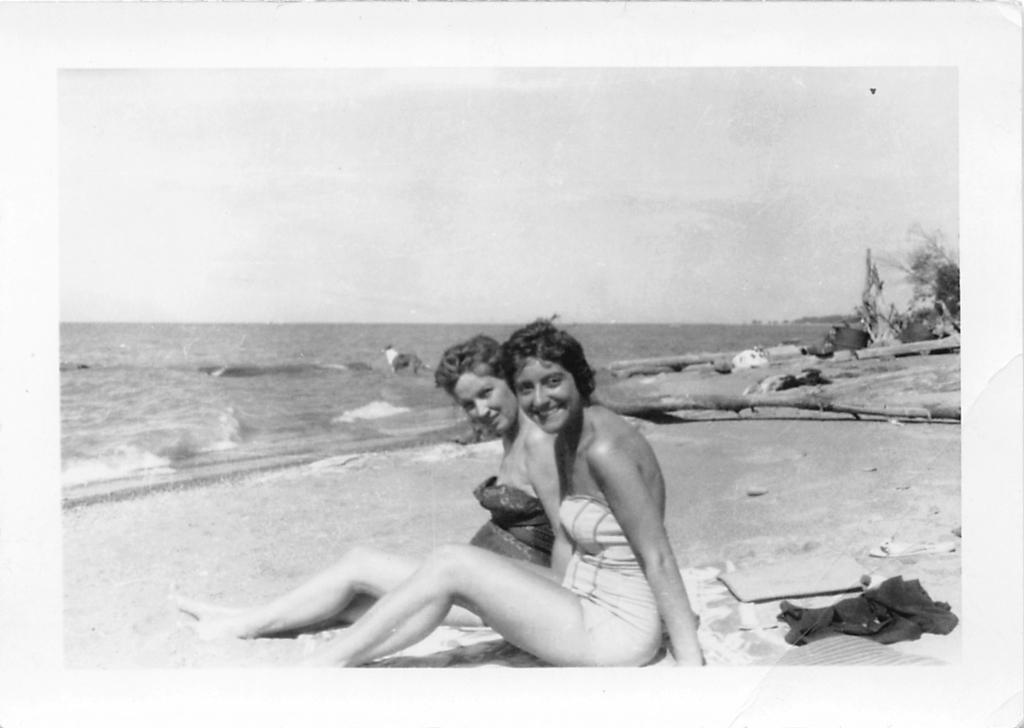How many people are in the image? There are two lady persons in the image. What are the lady persons wearing? They are wearing bikinis. Where are the lady persons located in the image? They are sitting at the seashore. What can be seen in the background of the image? There are trees and water visible in the background, and the sky is clear. What thoughts are going through the lady persons' minds in the image? There is no way to determine the thoughts of the lady persons in the image based on the provided facts. What is the condition of the lady persons' throats in the image? There is no information about the condition of the lady persons' throats in the image. 